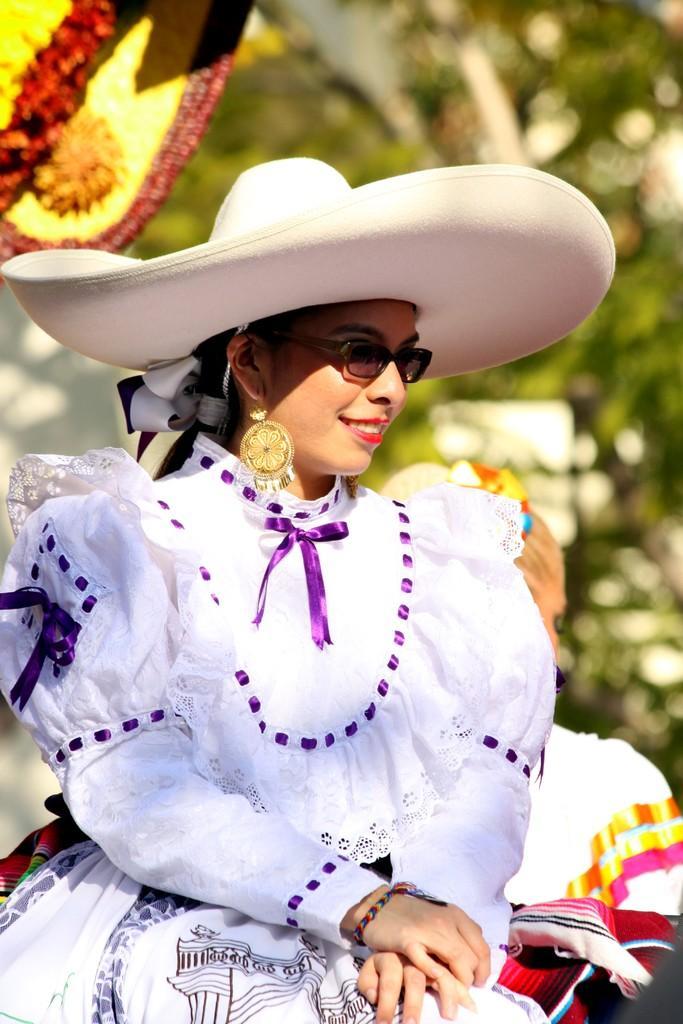Could you give a brief overview of what you see in this image? In this image in the center there is a woman wearing a white colour dress and white colour hat is smiling and the background is blurry. 